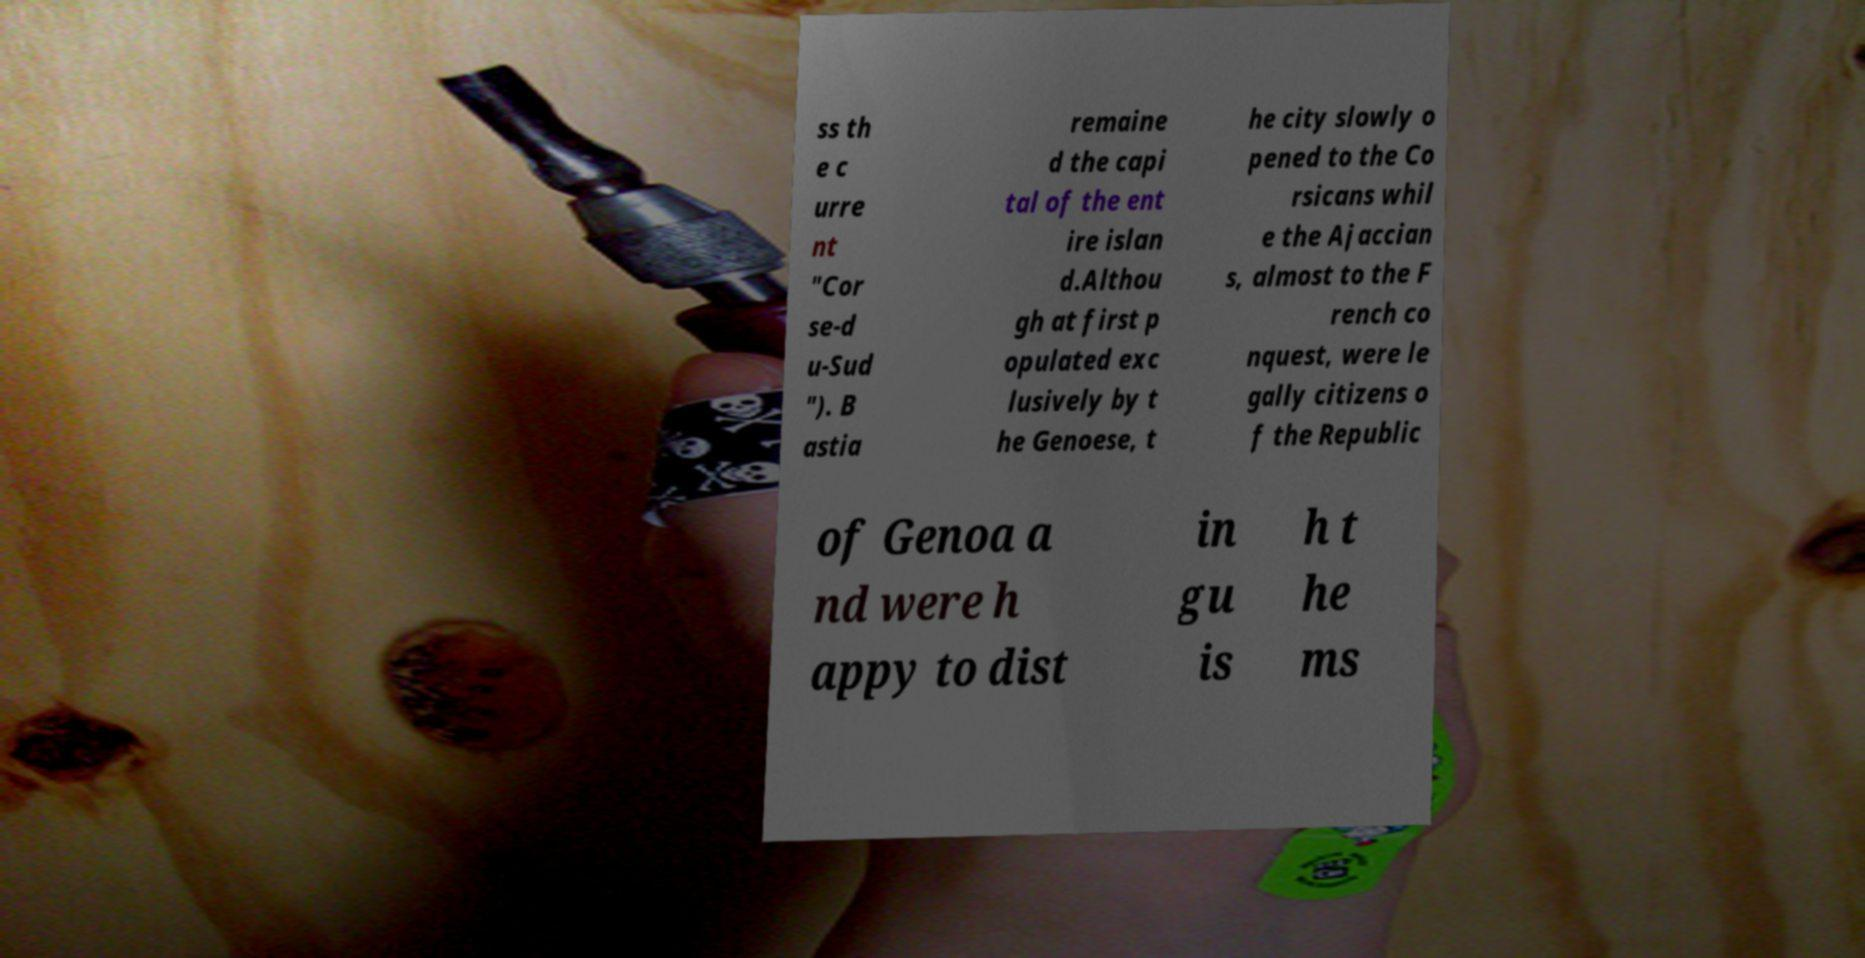Could you extract and type out the text from this image? ss th e c urre nt "Cor se-d u-Sud "). B astia remaine d the capi tal of the ent ire islan d.Althou gh at first p opulated exc lusively by t he Genoese, t he city slowly o pened to the Co rsicans whil e the Ajaccian s, almost to the F rench co nquest, were le gally citizens o f the Republic of Genoa a nd were h appy to dist in gu is h t he ms 